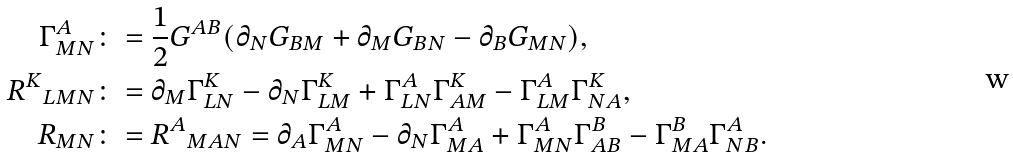<formula> <loc_0><loc_0><loc_500><loc_500>\Gamma ^ { A } _ { M N } & \colon = \frac { 1 } { 2 } G ^ { A B } ( \partial _ { N } G _ { B M } + \partial _ { M } G _ { B N } - \partial _ { B } G _ { M N } ) , \\ { R ^ { K } } _ { L M N } & \colon = \partial _ { M } \Gamma ^ { K } _ { L N } - \partial _ { N } \Gamma ^ { K } _ { L M } + \Gamma ^ { A } _ { L N } \Gamma ^ { K } _ { A M } - \Gamma ^ { A } _ { L M } \Gamma ^ { K } _ { N A } , \\ R _ { M N } & \colon = { R ^ { A } } _ { M A N } = \partial _ { A } \Gamma ^ { A } _ { M N } - \partial _ { N } \Gamma ^ { A } _ { M A } + \Gamma ^ { A } _ { M N } \Gamma ^ { B } _ { A B } - \Gamma ^ { B } _ { M A } \Gamma ^ { A } _ { N B } .</formula> 